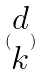Convert formula to latex. <formula><loc_0><loc_0><loc_500><loc_500>( \begin{matrix} d \\ k \end{matrix} )</formula> 